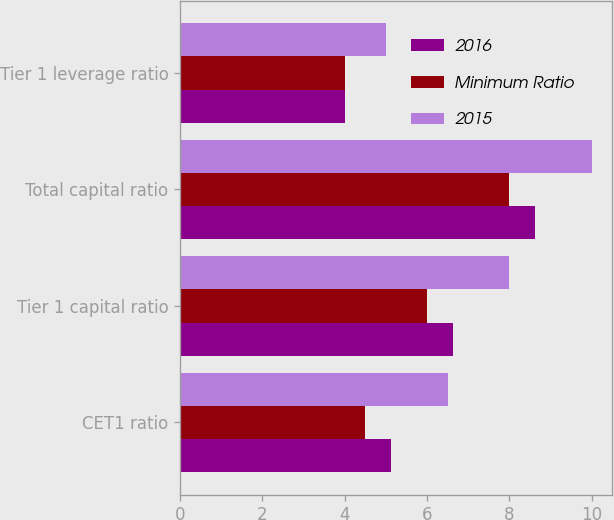<chart> <loc_0><loc_0><loc_500><loc_500><stacked_bar_chart><ecel><fcel>CET1 ratio<fcel>Tier 1 capital ratio<fcel>Total capital ratio<fcel>Tier 1 leverage ratio<nl><fcel>2016<fcel>5.12<fcel>6.62<fcel>8.62<fcel>4<nl><fcel>Minimum Ratio<fcel>4.5<fcel>6<fcel>8<fcel>4<nl><fcel>2015<fcel>6.5<fcel>8<fcel>10<fcel>5<nl></chart> 